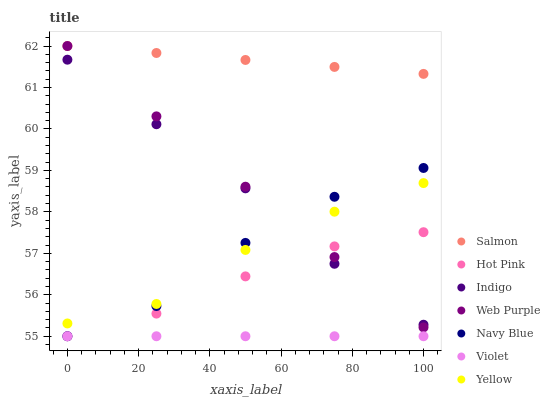Does Violet have the minimum area under the curve?
Answer yes or no. Yes. Does Salmon have the maximum area under the curve?
Answer yes or no. Yes. Does Navy Blue have the minimum area under the curve?
Answer yes or no. No. Does Navy Blue have the maximum area under the curve?
Answer yes or no. No. Is Violet the smoothest?
Answer yes or no. Yes. Is Navy Blue the roughest?
Answer yes or no. Yes. Is Hot Pink the smoothest?
Answer yes or no. No. Is Hot Pink the roughest?
Answer yes or no. No. Does Navy Blue have the lowest value?
Answer yes or no. Yes. Does Salmon have the lowest value?
Answer yes or no. No. Does Web Purple have the highest value?
Answer yes or no. Yes. Does Navy Blue have the highest value?
Answer yes or no. No. Is Violet less than Web Purple?
Answer yes or no. Yes. Is Salmon greater than Navy Blue?
Answer yes or no. Yes. Does Yellow intersect Web Purple?
Answer yes or no. Yes. Is Yellow less than Web Purple?
Answer yes or no. No. Is Yellow greater than Web Purple?
Answer yes or no. No. Does Violet intersect Web Purple?
Answer yes or no. No. 